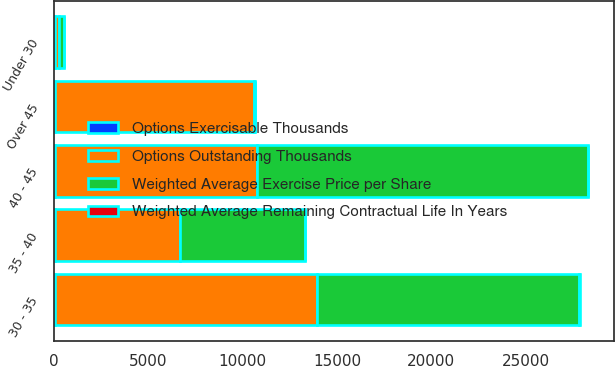Convert chart. <chart><loc_0><loc_0><loc_500><loc_500><stacked_bar_chart><ecel><fcel>Under 30<fcel>30 - 35<fcel>35 - 40<fcel>40 - 45<fcel>Over 45<nl><fcel>Options Outstanding Thousands<fcel>233<fcel>13915<fcel>6625<fcel>10730<fcel>10569<nl><fcel>Options Exercisable Thousands<fcel>26.85<fcel>33.45<fcel>37.42<fcel>41.33<fcel>48.91<nl><fcel>Weighted Average Exercise Price per Share<fcel>233<fcel>13915<fcel>6625<fcel>17520<fcel>48.91<nl><fcel>Weighted Average Remaining Contractual Life In Years<fcel>0.16<fcel>2.77<fcel>2.26<fcel>5.19<fcel>6.85<nl></chart> 